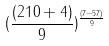Convert formula to latex. <formula><loc_0><loc_0><loc_500><loc_500>( \frac { ( 2 1 0 + 4 ) } { 9 } ) ^ { \frac { ( 7 - 5 7 ) } { 9 } }</formula> 